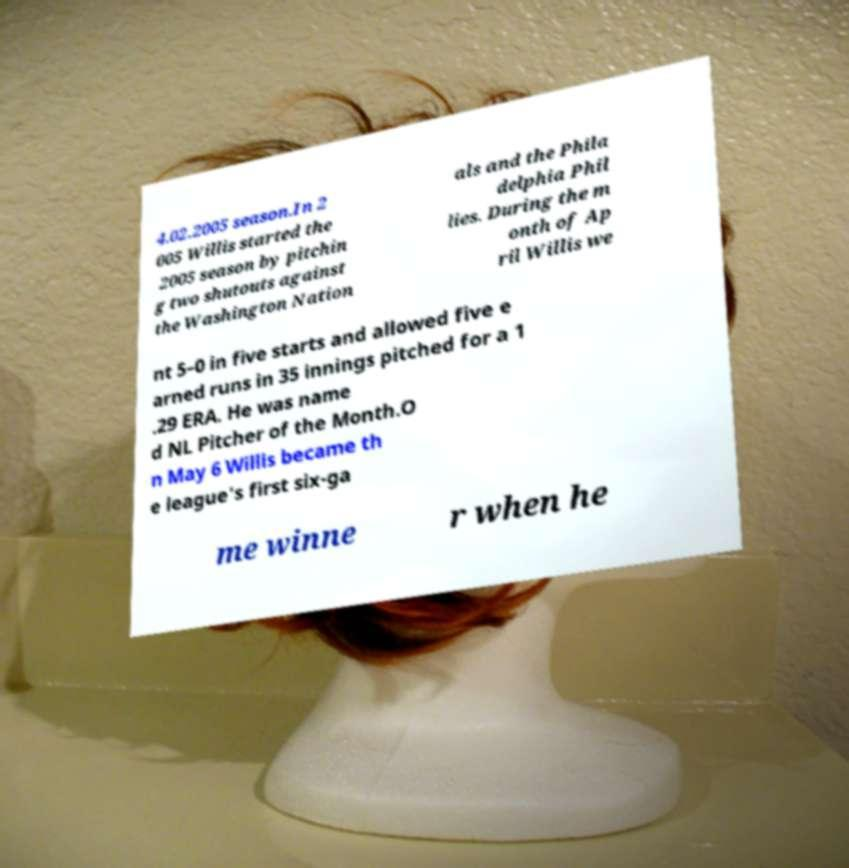Could you extract and type out the text from this image? 4.02.2005 season.In 2 005 Willis started the 2005 season by pitchin g two shutouts against the Washington Nation als and the Phila delphia Phil lies. During the m onth of Ap ril Willis we nt 5–0 in five starts and allowed five e arned runs in 35 innings pitched for a 1 .29 ERA. He was name d NL Pitcher of the Month.O n May 6 Willis became th e league's first six-ga me winne r when he 